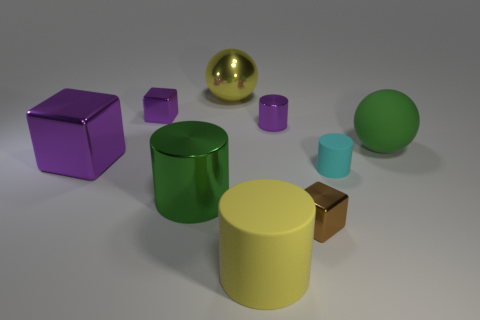Subtract all cylinders. How many objects are left? 5 Add 9 big blue matte cylinders. How many big blue matte cylinders exist? 9 Subtract 0 cyan spheres. How many objects are left? 9 Subtract all brown metal blocks. Subtract all tiny brown objects. How many objects are left? 7 Add 1 big things. How many big things are left? 6 